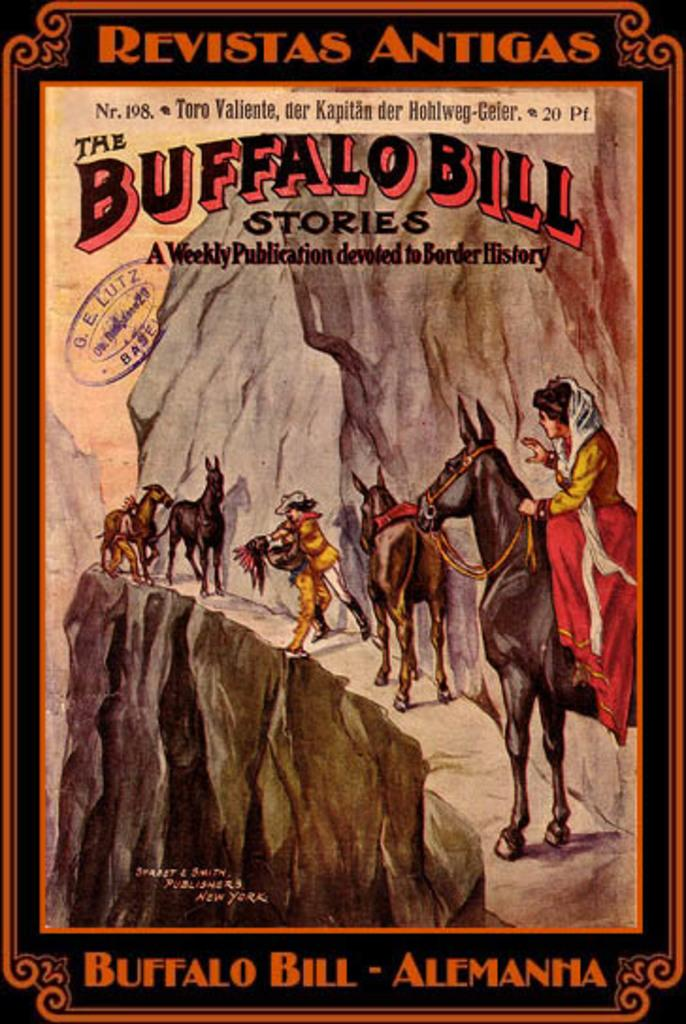What is the main subject of the paper in the image? The paper contains an image of persons, horses, and a hill. Can you describe the scene depicted on the paper? The paper contains an image of persons, horses, and a hill, suggesting a scene with people and animals on a hill. What type of silk material is used to create the parcel in the image? There is no parcel present in the image, and therefore no silk material can be observed. 